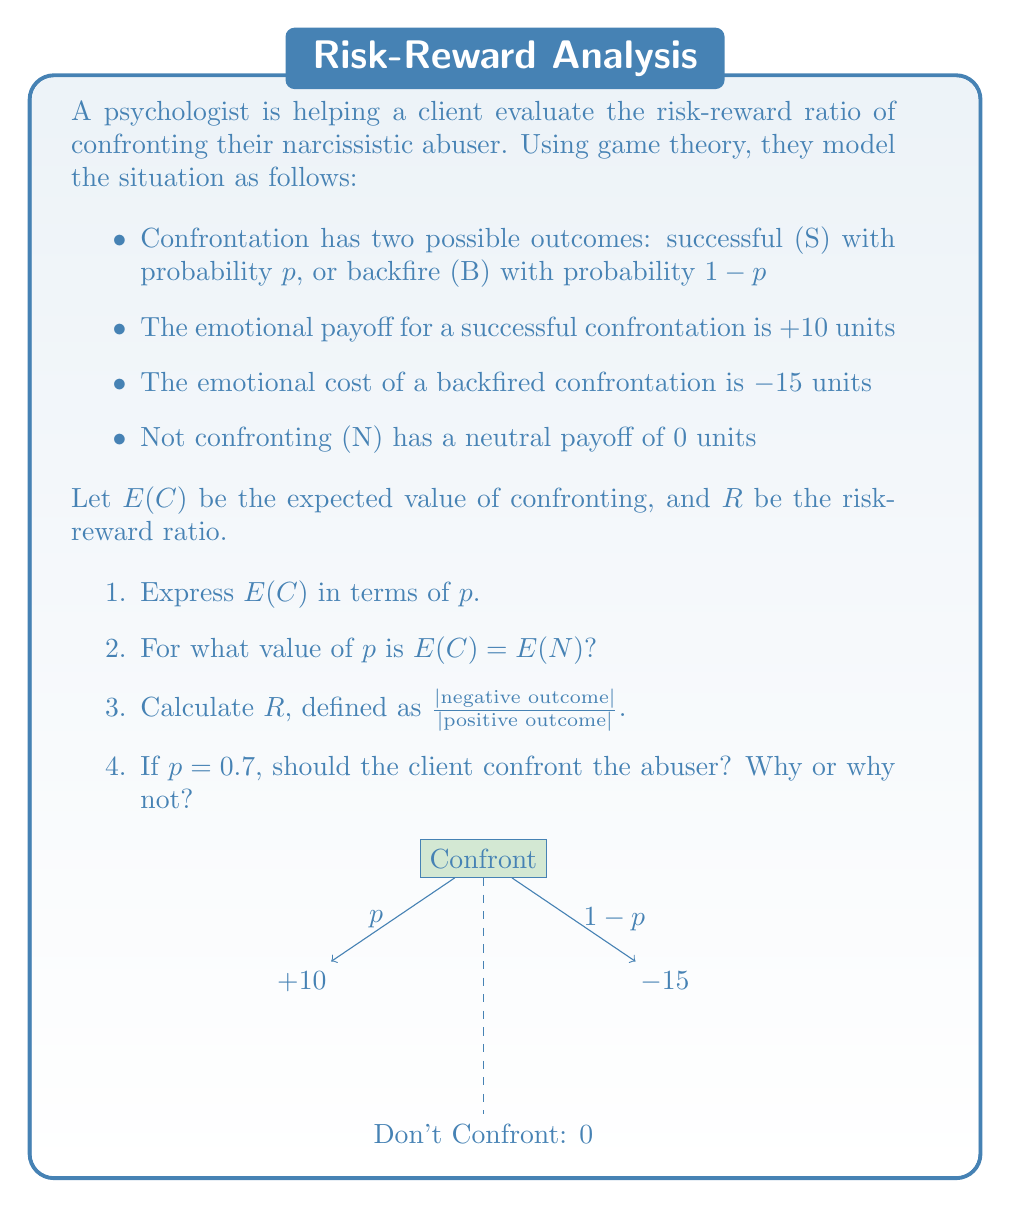What is the answer to this math problem? Let's approach this step-by-step:

1. To express E(C) in terms of p:
   E(C) = p(10) + (1-p)(-15)
   $$E(C) = 10p - 15 + 15p = 25p - 15$$

2. To find p when E(C) = E(N):
   $$25p - 15 = 0$$
   $$25p = 15$$
   $$p = \frac{15}{25} = 0.6$$

3. The risk-reward ratio R is:
   $$R = \frac{|\text{negative outcome}|}{|\text{positive outcome}|} = \frac{15}{10} = 1.5$$

4. If p = 0.7:
   E(C) = 25(0.7) - 15 = 17.5 - 15 = 2.5
   E(N) = 0

   Since E(C) > E(N) when p = 0.7, the client should confront the abuser. The expected emotional payoff (2.5 units) is positive and greater than the neutral payoff of not confronting.
Answer: 1. E(C) = 25p - 15
2. p = 0.6
3. R = 1.5
4. Yes, confront. E(C) > E(N) when p = 0.7 